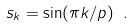Convert formula to latex. <formula><loc_0><loc_0><loc_500><loc_500>s _ { k } = \sin ( \pi k / p ) \ .</formula> 